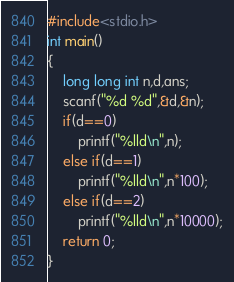<code> <loc_0><loc_0><loc_500><loc_500><_C_>#include<stdio.h>
int main()
{
    long long int n,d,ans;
    scanf("%d %d",&d,&n);
    if(d==0)
        printf("%lld\n",n);
    else if(d==1)
        printf("%lld\n",n*100);
    else if(d==2)
        printf("%lld\n",n*10000);
    return 0;
}
</code> 